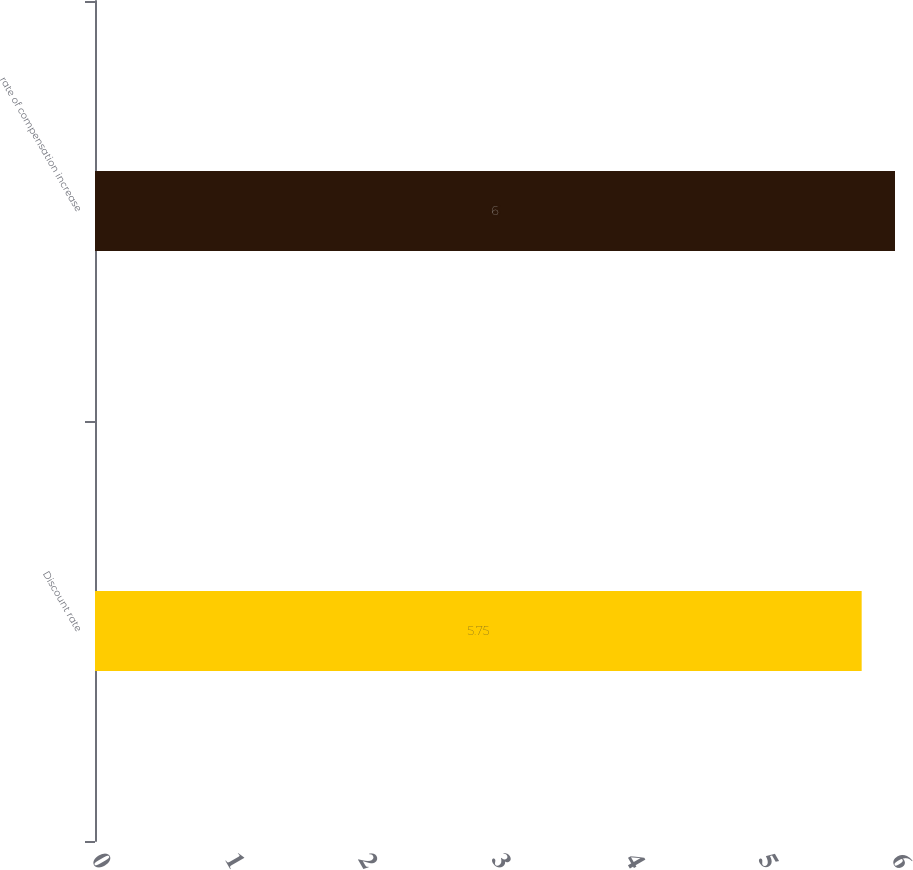Convert chart to OTSL. <chart><loc_0><loc_0><loc_500><loc_500><bar_chart><fcel>Discount rate<fcel>rate of compensation increase<nl><fcel>5.75<fcel>6<nl></chart> 